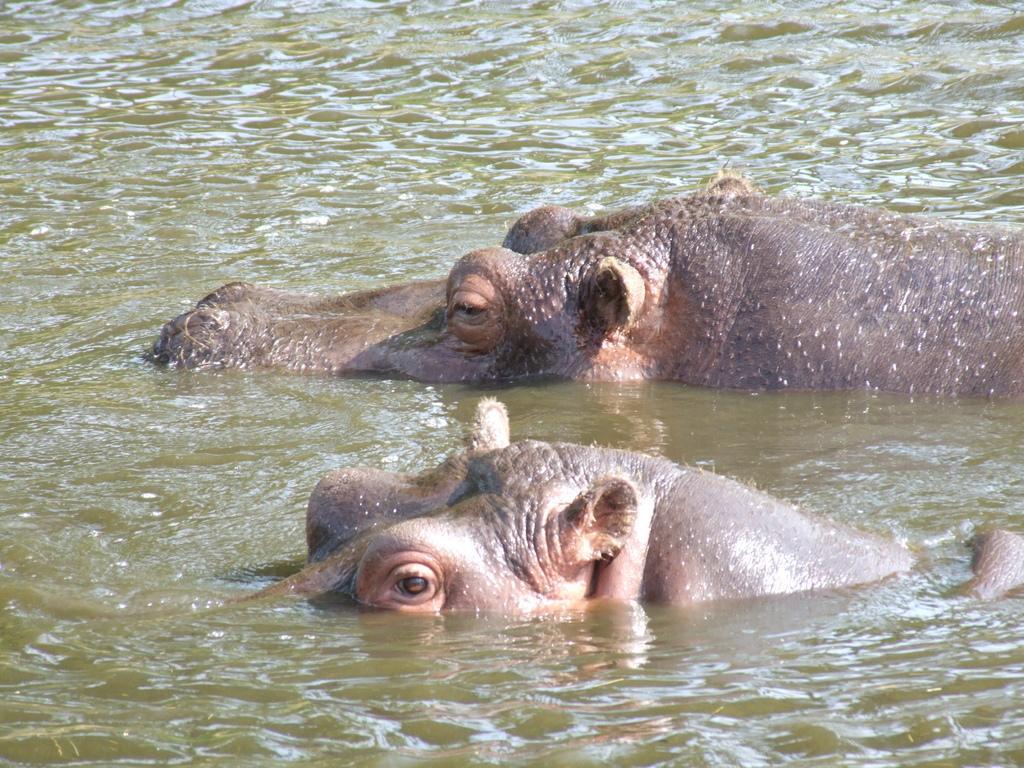Could you give a brief overview of what you see in this image? In this picture there are two rhinos in the water. 